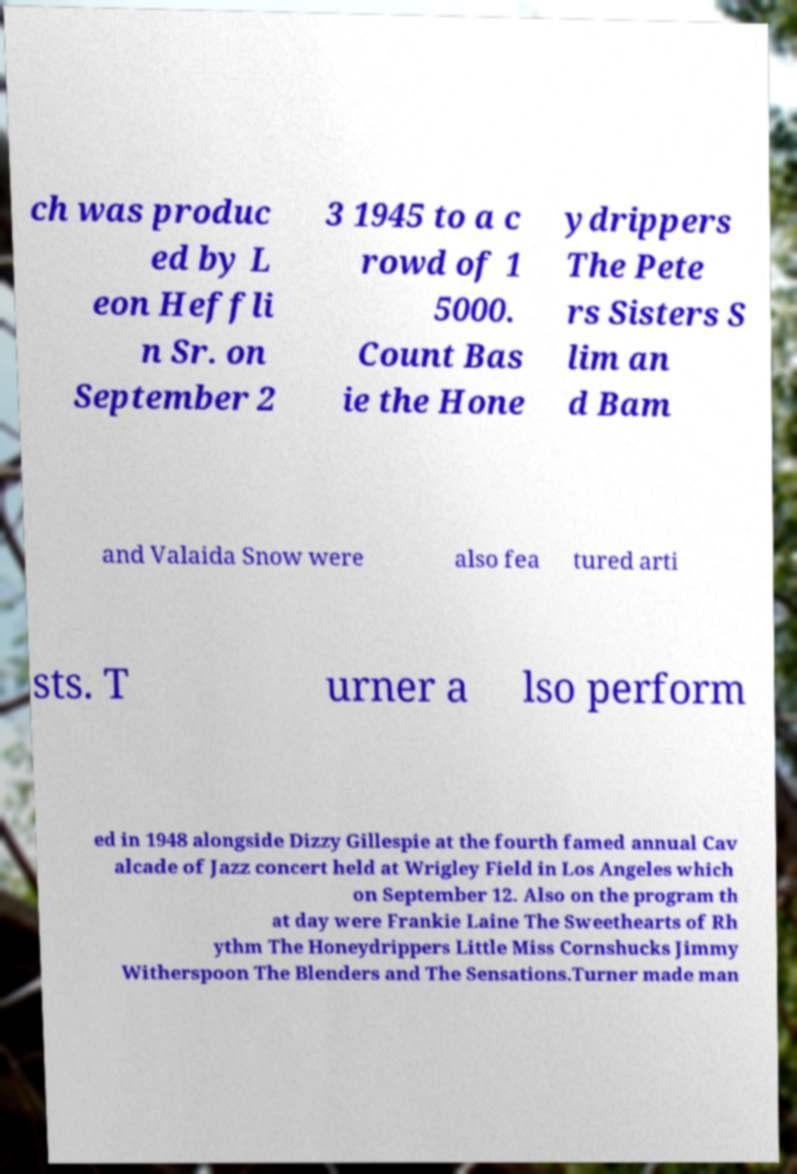Can you read and provide the text displayed in the image?This photo seems to have some interesting text. Can you extract and type it out for me? ch was produc ed by L eon Heffli n Sr. on September 2 3 1945 to a c rowd of 1 5000. Count Bas ie the Hone ydrippers The Pete rs Sisters S lim an d Bam and Valaida Snow were also fea tured arti sts. T urner a lso perform ed in 1948 alongside Dizzy Gillespie at the fourth famed annual Cav alcade of Jazz concert held at Wrigley Field in Los Angeles which on September 12. Also on the program th at day were Frankie Laine The Sweethearts of Rh ythm The Honeydrippers Little Miss Cornshucks Jimmy Witherspoon The Blenders and The Sensations.Turner made man 